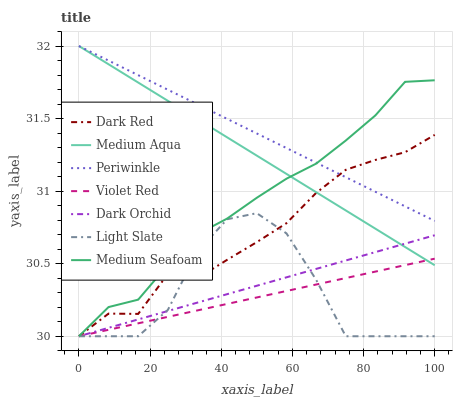Does Violet Red have the minimum area under the curve?
Answer yes or no. Yes. Does Periwinkle have the maximum area under the curve?
Answer yes or no. Yes. Does Light Slate have the minimum area under the curve?
Answer yes or no. No. Does Light Slate have the maximum area under the curve?
Answer yes or no. No. Is Dark Orchid the smoothest?
Answer yes or no. Yes. Is Light Slate the roughest?
Answer yes or no. Yes. Is Dark Red the smoothest?
Answer yes or no. No. Is Dark Red the roughest?
Answer yes or no. No. Does Violet Red have the lowest value?
Answer yes or no. Yes. Does Periwinkle have the lowest value?
Answer yes or no. No. Does Medium Aqua have the highest value?
Answer yes or no. Yes. Does Light Slate have the highest value?
Answer yes or no. No. Is Dark Orchid less than Periwinkle?
Answer yes or no. Yes. Is Medium Aqua greater than Light Slate?
Answer yes or no. Yes. Does Medium Seafoam intersect Violet Red?
Answer yes or no. Yes. Is Medium Seafoam less than Violet Red?
Answer yes or no. No. Is Medium Seafoam greater than Violet Red?
Answer yes or no. No. Does Dark Orchid intersect Periwinkle?
Answer yes or no. No. 